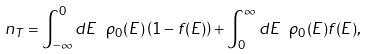<formula> <loc_0><loc_0><loc_500><loc_500>n _ { T } = \int _ { - \infty } ^ { 0 } d E \ \rho _ { 0 } ( E ) \left ( 1 - f ( E ) \right ) + \int _ { 0 } ^ { \infty } d E \ \rho _ { 0 } ( E ) f ( E ) ,</formula> 